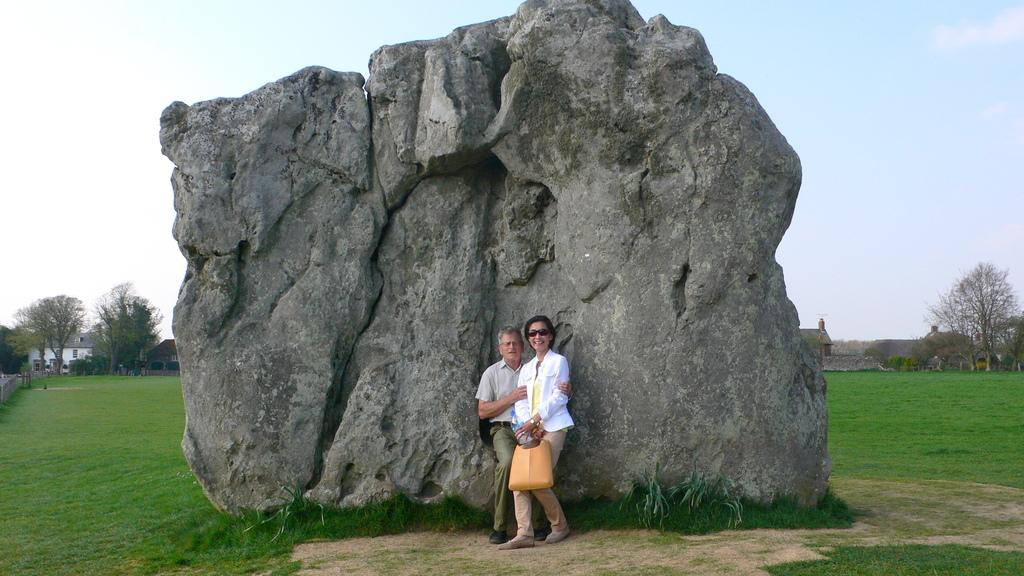Who can be seen in the image? There is a couple in the image. What are the couple doing in the image? The couple is standing. What is located behind the couple? There is a rock behind the couple. What type of vegetation is present in the image? There is grass and trees in the image. What can be seen in the background of the image? There are buildings in the background of the image. What type of hose is being used by the guide in the image? There is no guide or hose present in the image. What country is the couple from in the image? The country of origin for the couple cannot be determined from the image. 